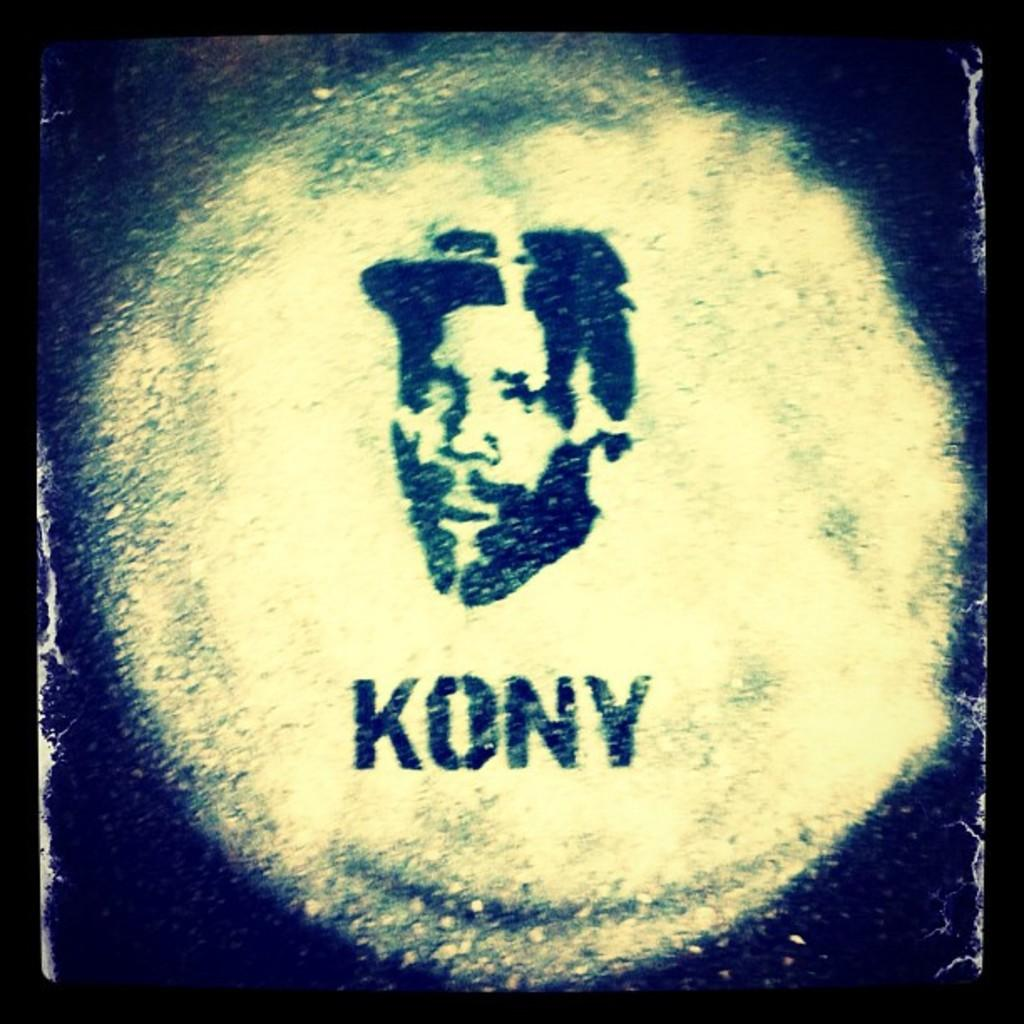What is present on the poster in the image? There is a poster in the image, which contains a word. Is there any image or illustration on the poster? Yes, the poster includes a photo of a person. What type of balance is demonstrated by the secretary in the image? There is no secretary present in the image, and therefore no balance can be observed. 